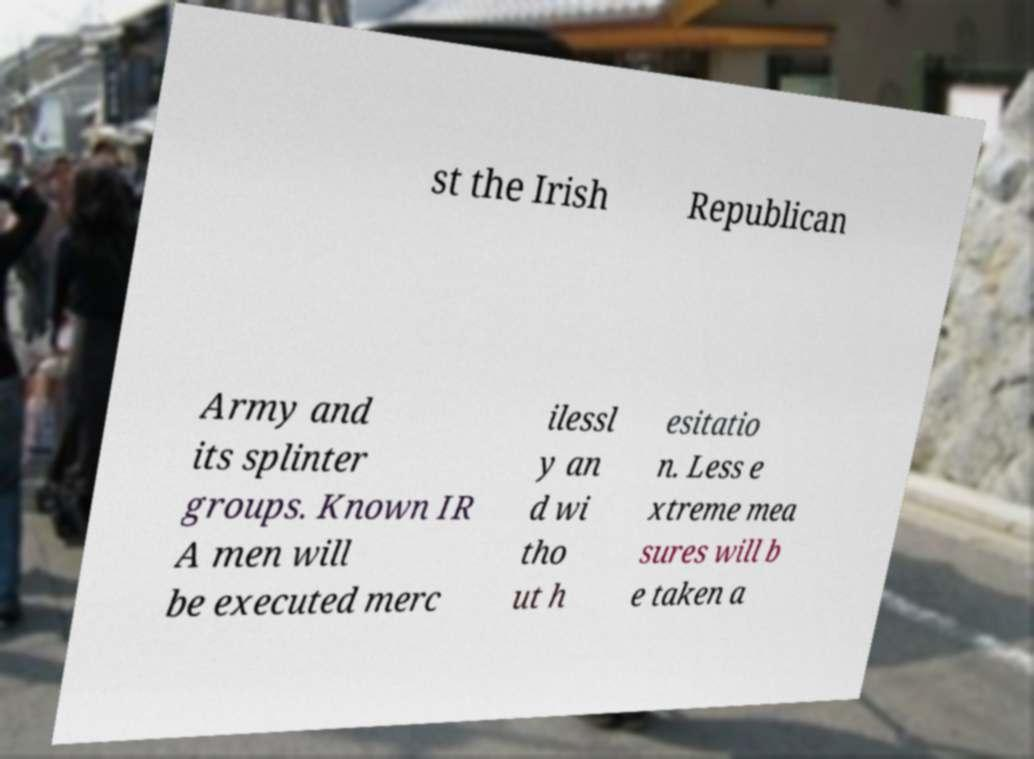Can you accurately transcribe the text from the provided image for me? st the Irish Republican Army and its splinter groups. Known IR A men will be executed merc ilessl y an d wi tho ut h esitatio n. Less e xtreme mea sures will b e taken a 